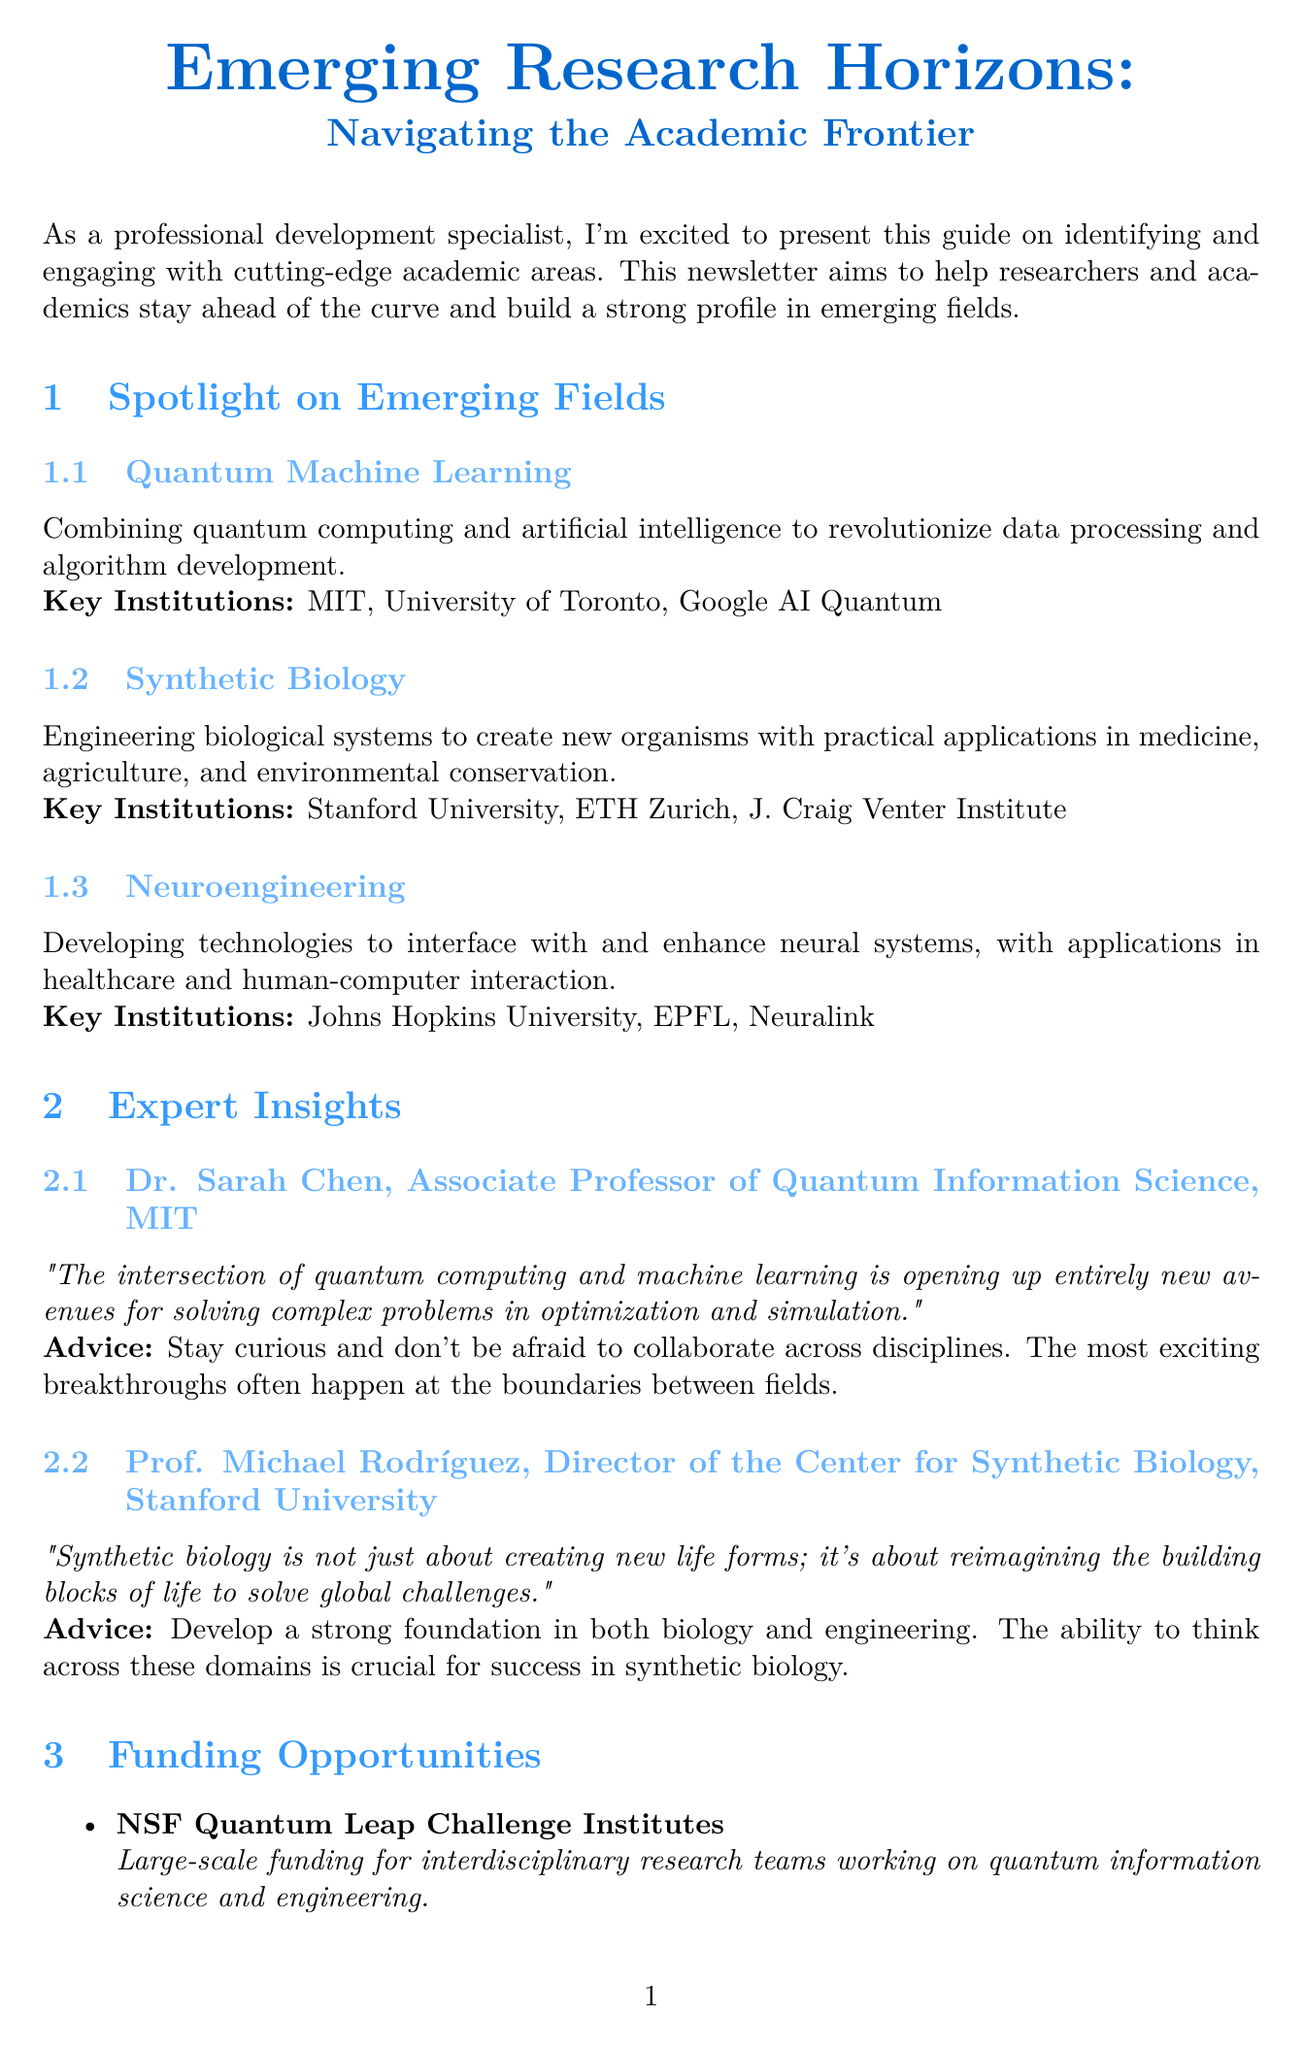What is the title of the newsletter? The title is provided at the beginning of the document, which is "Emerging Research Horizons: Navigating the Academic Frontier."
Answer: Emerging Research Horizons: Navigating the Academic Frontier How many emerging fields are highlighted in the newsletter? The document lists three emerging fields in the section on Emerging Fields.
Answer: 3 Who is the Director of the Center for Synthetic Biology? The document mentions the Director's name and position in the Expert Insights section.
Answer: Prof. Michael Rodríguez What is the funding opportunity with a deadline of January 15, 2024? The document specifies funding opportunities along with their deadlines, highlighting one that matches the date.
Answer: DARPA Young Faculty Award What advice does Dr. Sarah Chen give about collaboration? The document includes quotes and advice from experts, one of which is attributed to Dr. Sarah Chen.
Answer: "Stay curious and don't be afraid to collaborate across disciplines." Which institution is associated with Neuroengineering? The document lists key institutions for each emerging field, including Neuroengineering.
Answer: Johns Hopkins University What is one networking tip mentioned in the newsletter? The document provides networking tips in a dedicated section, allowing for retrieval of specific suggestions.
Answer: Attend specialized conferences What is the focus of the NSF Quantum Leap Challenge Institutes? The document describes different funding opportunities, including the focus of this particular program.
Answer: Interdisciplinary research teams working on quantum information science and engineering Which conference is related to Quantum Computing? The document lists networking tips, one of which specifies a conference related to Quantum Computing.
Answer: International Conference on Quantum Computing (ICQC) 